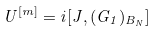<formula> <loc_0><loc_0><loc_500><loc_500>U ^ { [ m ] } = i [ J , ( G _ { 1 } ) _ { B _ { N } } ]</formula> 